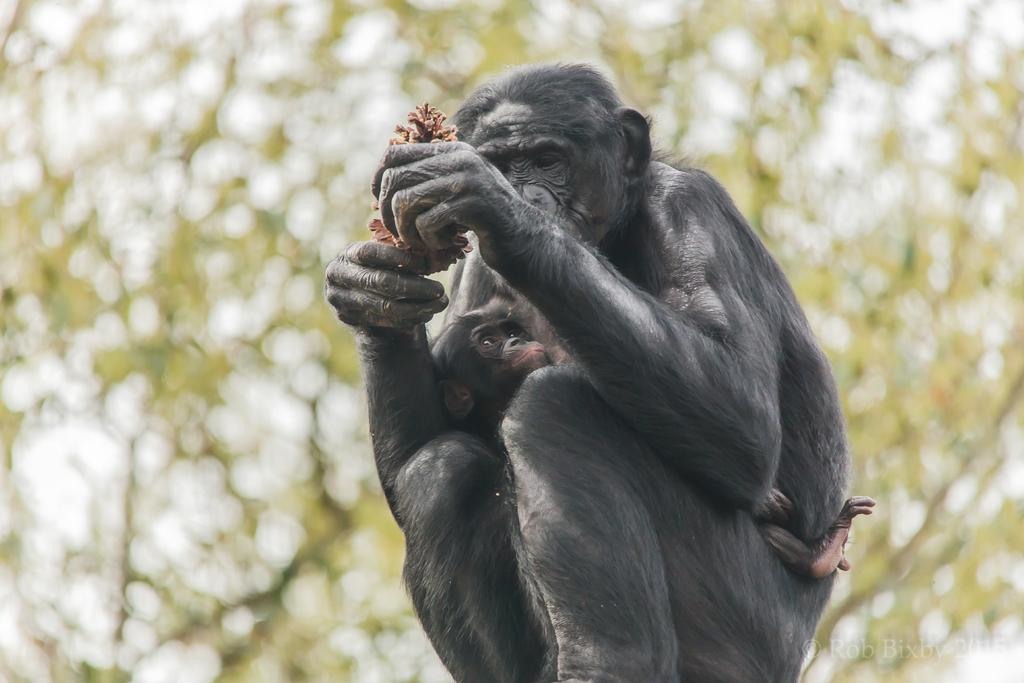What animal is the main subject of the picture? There is a monkey in the picture. What is the monkey doing in the picture? The monkey is sitting. What is the monkey holding in its hand? The monkey is holding something in its hand, but we cannot determine what it is from the image. Is there a baby monkey present in the picture? Yes, there is a baby monkey sitting on the monkey. What can be seen in the background of the picture? There is a tree in the background of the picture. What type of question is the monkey asking the crowd in the image? There is no crowd present in the image, and the monkey is not asking any questions. 